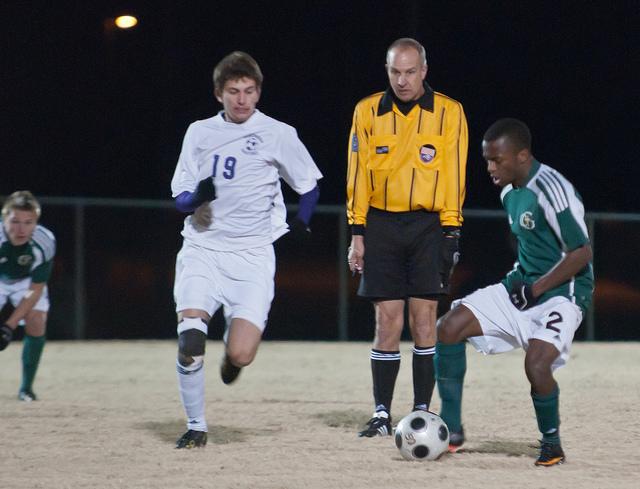What does the man in the yellow shirt do?
Give a very brief answer. Referee. What number is on the white jersey?
Give a very brief answer. 19. What are the boys kicking?
Be succinct. Soccer ball. 